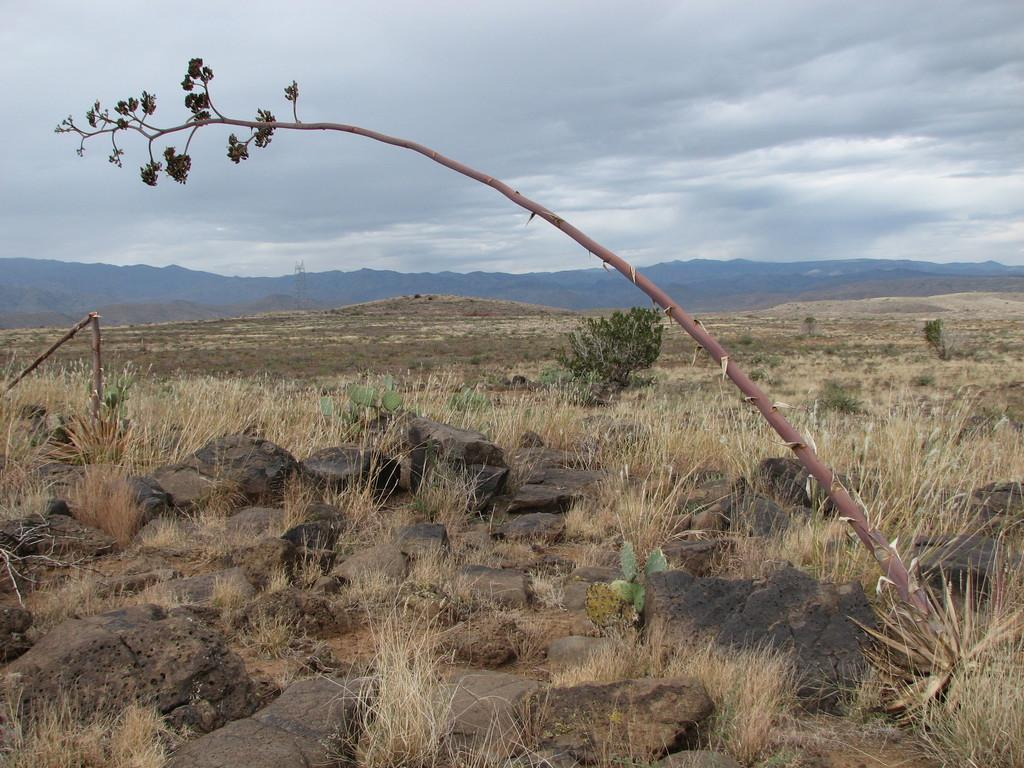What type of vegetation can be seen in the front of the image? There is grass and plants in the front of the image. What other objects can be seen in the front of the image? There is a branch and rocks in the front of the image. What is the condition of the sky in the background of the image? The sky is cloudy in the background of the image. What type of landscape can be seen in the background of the image? There are hills in the background of the image. Can you see a guitar being played on the hills in the background of the image? There is no guitar or anyone playing it in the image. Is there a sofa visible among the rocks in the front of the image? There is no sofa present in the image. 